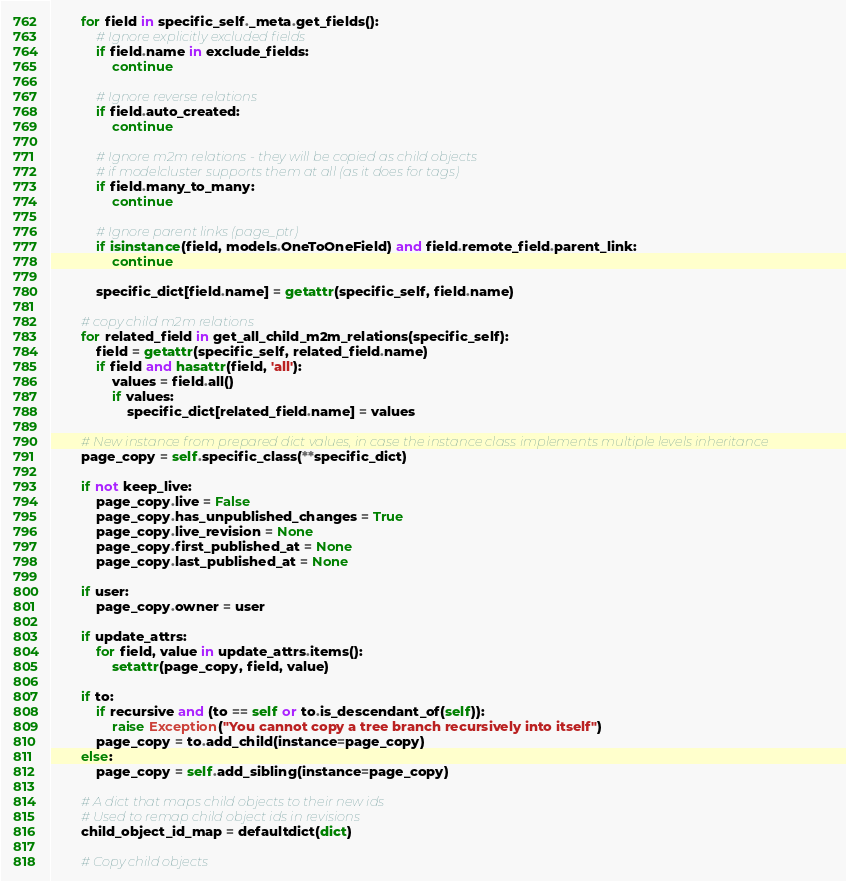<code> <loc_0><loc_0><loc_500><loc_500><_Python_>
        for field in specific_self._meta.get_fields():
            # Ignore explicitly excluded fields
            if field.name in exclude_fields:
                continue

            # Ignore reverse relations
            if field.auto_created:
                continue

            # Ignore m2m relations - they will be copied as child objects
            # if modelcluster supports them at all (as it does for tags)
            if field.many_to_many:
                continue

            # Ignore parent links (page_ptr)
            if isinstance(field, models.OneToOneField) and field.remote_field.parent_link:
                continue

            specific_dict[field.name] = getattr(specific_self, field.name)

        # copy child m2m relations
        for related_field in get_all_child_m2m_relations(specific_self):
            field = getattr(specific_self, related_field.name)
            if field and hasattr(field, 'all'):
                values = field.all()
                if values:
                    specific_dict[related_field.name] = values

        # New instance from prepared dict values, in case the instance class implements multiple levels inheritance
        page_copy = self.specific_class(**specific_dict)

        if not keep_live:
            page_copy.live = False
            page_copy.has_unpublished_changes = True
            page_copy.live_revision = None
            page_copy.first_published_at = None
            page_copy.last_published_at = None

        if user:
            page_copy.owner = user

        if update_attrs:
            for field, value in update_attrs.items():
                setattr(page_copy, field, value)

        if to:
            if recursive and (to == self or to.is_descendant_of(self)):
                raise Exception("You cannot copy a tree branch recursively into itself")
            page_copy = to.add_child(instance=page_copy)
        else:
            page_copy = self.add_sibling(instance=page_copy)

        # A dict that maps child objects to their new ids
        # Used to remap child object ids in revisions
        child_object_id_map = defaultdict(dict)

        # Copy child objects</code> 